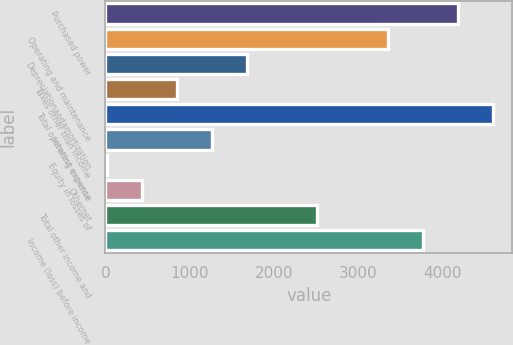Convert chart. <chart><loc_0><loc_0><loc_500><loc_500><bar_chart><fcel>Purchased power<fcel>Operating and maintenance<fcel>Depreciationandamortization<fcel>Taxes other than income<fcel>Total operating expense<fcel>Interest expense<fcel>Equity in losses of<fcel>Othernet<fcel>Total other income and<fcel>Income (loss) before income<nl><fcel>4186<fcel>3352.6<fcel>1685.8<fcel>852.4<fcel>4602.7<fcel>1269.1<fcel>19<fcel>435.7<fcel>2519.2<fcel>3769.3<nl></chart> 